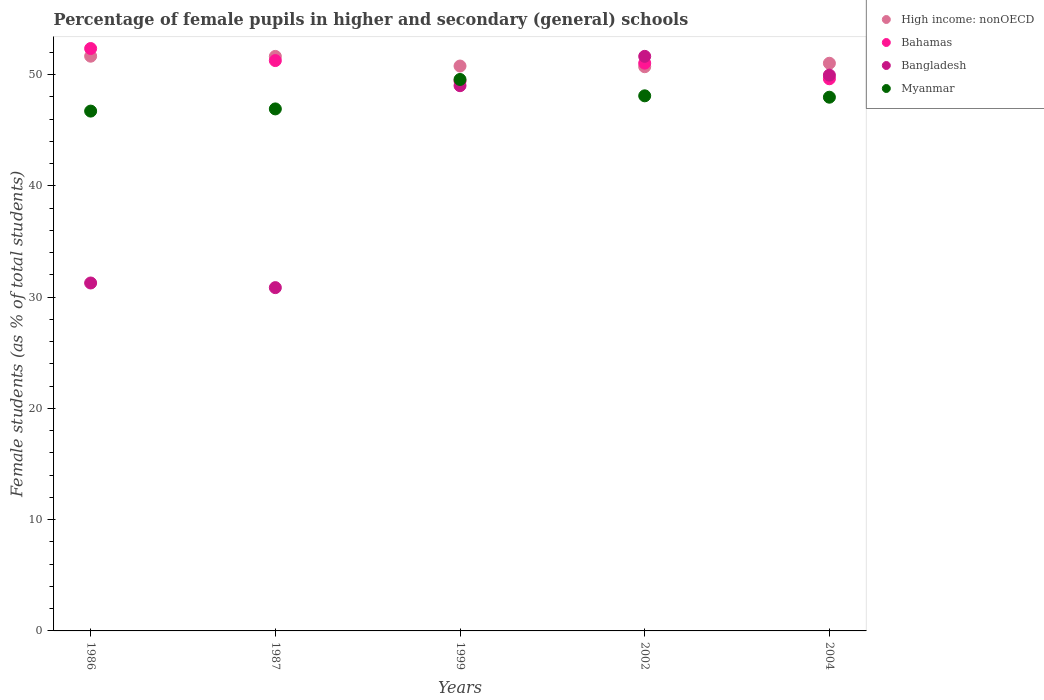How many different coloured dotlines are there?
Give a very brief answer. 4. What is the percentage of female pupils in higher and secondary schools in Bangladesh in 2002?
Provide a short and direct response. 51.64. Across all years, what is the maximum percentage of female pupils in higher and secondary schools in Bahamas?
Give a very brief answer. 52.34. Across all years, what is the minimum percentage of female pupils in higher and secondary schools in Bahamas?
Offer a terse response. 49.43. What is the total percentage of female pupils in higher and secondary schools in Myanmar in the graph?
Provide a succinct answer. 239.25. What is the difference between the percentage of female pupils in higher and secondary schools in High income: nonOECD in 2002 and that in 2004?
Provide a short and direct response. -0.31. What is the difference between the percentage of female pupils in higher and secondary schools in Bangladesh in 1986 and the percentage of female pupils in higher and secondary schools in High income: nonOECD in 1987?
Give a very brief answer. -20.36. What is the average percentage of female pupils in higher and secondary schools in Bahamas per year?
Your answer should be very brief. 50.73. In the year 1999, what is the difference between the percentage of female pupils in higher and secondary schools in High income: nonOECD and percentage of female pupils in higher and secondary schools in Myanmar?
Offer a terse response. 1.21. In how many years, is the percentage of female pupils in higher and secondary schools in Bangladesh greater than 48 %?
Give a very brief answer. 3. What is the ratio of the percentage of female pupils in higher and secondary schools in Bahamas in 2002 to that in 2004?
Provide a short and direct response. 1.03. What is the difference between the highest and the second highest percentage of female pupils in higher and secondary schools in Bangladesh?
Your response must be concise. 1.69. What is the difference between the highest and the lowest percentage of female pupils in higher and secondary schools in High income: nonOECD?
Ensure brevity in your answer.  0.94. In how many years, is the percentage of female pupils in higher and secondary schools in Bahamas greater than the average percentage of female pupils in higher and secondary schools in Bahamas taken over all years?
Your response must be concise. 3. Is it the case that in every year, the sum of the percentage of female pupils in higher and secondary schools in Bangladesh and percentage of female pupils in higher and secondary schools in High income: nonOECD  is greater than the percentage of female pupils in higher and secondary schools in Bahamas?
Your answer should be very brief. Yes. Is the percentage of female pupils in higher and secondary schools in Myanmar strictly greater than the percentage of female pupils in higher and secondary schools in High income: nonOECD over the years?
Your answer should be very brief. No. How many dotlines are there?
Ensure brevity in your answer.  4. How many years are there in the graph?
Ensure brevity in your answer.  5. What is the difference between two consecutive major ticks on the Y-axis?
Keep it short and to the point. 10. Does the graph contain any zero values?
Your answer should be compact. No. Does the graph contain grids?
Offer a very short reply. No. Where does the legend appear in the graph?
Your answer should be very brief. Top right. How many legend labels are there?
Ensure brevity in your answer.  4. How are the legend labels stacked?
Make the answer very short. Vertical. What is the title of the graph?
Give a very brief answer. Percentage of female pupils in higher and secondary (general) schools. Does "Togo" appear as one of the legend labels in the graph?
Your response must be concise. No. What is the label or title of the X-axis?
Offer a very short reply. Years. What is the label or title of the Y-axis?
Your response must be concise. Female students (as % of total students). What is the Female students (as % of total students) of High income: nonOECD in 1986?
Make the answer very short. 51.65. What is the Female students (as % of total students) of Bahamas in 1986?
Give a very brief answer. 52.34. What is the Female students (as % of total students) in Bangladesh in 1986?
Offer a very short reply. 31.27. What is the Female students (as % of total students) in Myanmar in 1986?
Provide a short and direct response. 46.72. What is the Female students (as % of total students) of High income: nonOECD in 1987?
Offer a very short reply. 51.63. What is the Female students (as % of total students) in Bahamas in 1987?
Make the answer very short. 51.26. What is the Female students (as % of total students) of Bangladesh in 1987?
Ensure brevity in your answer.  30.85. What is the Female students (as % of total students) of Myanmar in 1987?
Your answer should be very brief. 46.91. What is the Female students (as % of total students) in High income: nonOECD in 1999?
Keep it short and to the point. 50.77. What is the Female students (as % of total students) in Bahamas in 1999?
Keep it short and to the point. 49.43. What is the Female students (as % of total students) in Bangladesh in 1999?
Your response must be concise. 49. What is the Female students (as % of total students) in Myanmar in 1999?
Your response must be concise. 49.56. What is the Female students (as % of total students) of High income: nonOECD in 2002?
Offer a very short reply. 50.71. What is the Female students (as % of total students) in Bahamas in 2002?
Give a very brief answer. 51.03. What is the Female students (as % of total students) of Bangladesh in 2002?
Provide a short and direct response. 51.64. What is the Female students (as % of total students) of Myanmar in 2002?
Provide a succinct answer. 48.09. What is the Female students (as % of total students) of High income: nonOECD in 2004?
Your response must be concise. 51.02. What is the Female students (as % of total students) of Bahamas in 2004?
Make the answer very short. 49.62. What is the Female students (as % of total students) in Bangladesh in 2004?
Make the answer very short. 49.95. What is the Female students (as % of total students) in Myanmar in 2004?
Ensure brevity in your answer.  47.97. Across all years, what is the maximum Female students (as % of total students) in High income: nonOECD?
Your answer should be compact. 51.65. Across all years, what is the maximum Female students (as % of total students) of Bahamas?
Ensure brevity in your answer.  52.34. Across all years, what is the maximum Female students (as % of total students) in Bangladesh?
Your response must be concise. 51.64. Across all years, what is the maximum Female students (as % of total students) of Myanmar?
Provide a short and direct response. 49.56. Across all years, what is the minimum Female students (as % of total students) in High income: nonOECD?
Offer a terse response. 50.71. Across all years, what is the minimum Female students (as % of total students) of Bahamas?
Give a very brief answer. 49.43. Across all years, what is the minimum Female students (as % of total students) in Bangladesh?
Provide a short and direct response. 30.85. Across all years, what is the minimum Female students (as % of total students) in Myanmar?
Keep it short and to the point. 46.72. What is the total Female students (as % of total students) of High income: nonOECD in the graph?
Ensure brevity in your answer.  255.77. What is the total Female students (as % of total students) of Bahamas in the graph?
Your answer should be compact. 253.67. What is the total Female students (as % of total students) in Bangladesh in the graph?
Offer a very short reply. 212.71. What is the total Female students (as % of total students) in Myanmar in the graph?
Make the answer very short. 239.25. What is the difference between the Female students (as % of total students) in High income: nonOECD in 1986 and that in 1987?
Offer a very short reply. 0.02. What is the difference between the Female students (as % of total students) of Bahamas in 1986 and that in 1987?
Offer a very short reply. 1.08. What is the difference between the Female students (as % of total students) in Bangladesh in 1986 and that in 1987?
Keep it short and to the point. 0.42. What is the difference between the Female students (as % of total students) in Myanmar in 1986 and that in 1987?
Offer a very short reply. -0.2. What is the difference between the Female students (as % of total students) of High income: nonOECD in 1986 and that in 1999?
Offer a very short reply. 0.88. What is the difference between the Female students (as % of total students) of Bahamas in 1986 and that in 1999?
Keep it short and to the point. 2.92. What is the difference between the Female students (as % of total students) in Bangladesh in 1986 and that in 1999?
Make the answer very short. -17.73. What is the difference between the Female students (as % of total students) in Myanmar in 1986 and that in 1999?
Provide a succinct answer. -2.84. What is the difference between the Female students (as % of total students) in High income: nonOECD in 1986 and that in 2002?
Provide a succinct answer. 0.94. What is the difference between the Female students (as % of total students) in Bahamas in 1986 and that in 2002?
Your answer should be compact. 1.31. What is the difference between the Female students (as % of total students) in Bangladesh in 1986 and that in 2002?
Your response must be concise. -20.37. What is the difference between the Female students (as % of total students) in Myanmar in 1986 and that in 2002?
Offer a terse response. -1.37. What is the difference between the Female students (as % of total students) in High income: nonOECD in 1986 and that in 2004?
Provide a short and direct response. 0.63. What is the difference between the Female students (as % of total students) in Bahamas in 1986 and that in 2004?
Make the answer very short. 2.72. What is the difference between the Female students (as % of total students) of Bangladesh in 1986 and that in 2004?
Your response must be concise. -18.68. What is the difference between the Female students (as % of total students) of Myanmar in 1986 and that in 2004?
Your answer should be compact. -1.25. What is the difference between the Female students (as % of total students) in High income: nonOECD in 1987 and that in 1999?
Your response must be concise. 0.87. What is the difference between the Female students (as % of total students) of Bahamas in 1987 and that in 1999?
Give a very brief answer. 1.83. What is the difference between the Female students (as % of total students) in Bangladesh in 1987 and that in 1999?
Offer a terse response. -18.15. What is the difference between the Female students (as % of total students) in Myanmar in 1987 and that in 1999?
Provide a short and direct response. -2.65. What is the difference between the Female students (as % of total students) of High income: nonOECD in 1987 and that in 2002?
Give a very brief answer. 0.93. What is the difference between the Female students (as % of total students) in Bahamas in 1987 and that in 2002?
Provide a succinct answer. 0.23. What is the difference between the Female students (as % of total students) in Bangladesh in 1987 and that in 2002?
Provide a succinct answer. -20.79. What is the difference between the Female students (as % of total students) of Myanmar in 1987 and that in 2002?
Provide a short and direct response. -1.18. What is the difference between the Female students (as % of total students) in High income: nonOECD in 1987 and that in 2004?
Your answer should be compact. 0.62. What is the difference between the Female students (as % of total students) in Bahamas in 1987 and that in 2004?
Provide a succinct answer. 1.64. What is the difference between the Female students (as % of total students) in Bangladesh in 1987 and that in 2004?
Offer a terse response. -19.1. What is the difference between the Female students (as % of total students) of Myanmar in 1987 and that in 2004?
Keep it short and to the point. -1.05. What is the difference between the Female students (as % of total students) of High income: nonOECD in 1999 and that in 2002?
Your answer should be compact. 0.06. What is the difference between the Female students (as % of total students) in Bahamas in 1999 and that in 2002?
Provide a succinct answer. -1.6. What is the difference between the Female students (as % of total students) in Bangladesh in 1999 and that in 2002?
Offer a very short reply. -2.64. What is the difference between the Female students (as % of total students) of Myanmar in 1999 and that in 2002?
Make the answer very short. 1.47. What is the difference between the Female students (as % of total students) of High income: nonOECD in 1999 and that in 2004?
Provide a succinct answer. -0.25. What is the difference between the Female students (as % of total students) of Bahamas in 1999 and that in 2004?
Keep it short and to the point. -0.2. What is the difference between the Female students (as % of total students) in Bangladesh in 1999 and that in 2004?
Your answer should be very brief. -0.95. What is the difference between the Female students (as % of total students) in Myanmar in 1999 and that in 2004?
Provide a short and direct response. 1.59. What is the difference between the Female students (as % of total students) of High income: nonOECD in 2002 and that in 2004?
Offer a very short reply. -0.31. What is the difference between the Female students (as % of total students) of Bahamas in 2002 and that in 2004?
Give a very brief answer. 1.4. What is the difference between the Female students (as % of total students) of Bangladesh in 2002 and that in 2004?
Offer a very short reply. 1.69. What is the difference between the Female students (as % of total students) in Myanmar in 2002 and that in 2004?
Provide a succinct answer. 0.12. What is the difference between the Female students (as % of total students) of High income: nonOECD in 1986 and the Female students (as % of total students) of Bahamas in 1987?
Your response must be concise. 0.39. What is the difference between the Female students (as % of total students) in High income: nonOECD in 1986 and the Female students (as % of total students) in Bangladesh in 1987?
Offer a terse response. 20.8. What is the difference between the Female students (as % of total students) of High income: nonOECD in 1986 and the Female students (as % of total students) of Myanmar in 1987?
Your response must be concise. 4.74. What is the difference between the Female students (as % of total students) in Bahamas in 1986 and the Female students (as % of total students) in Bangladesh in 1987?
Your answer should be compact. 21.49. What is the difference between the Female students (as % of total students) of Bahamas in 1986 and the Female students (as % of total students) of Myanmar in 1987?
Your answer should be compact. 5.43. What is the difference between the Female students (as % of total students) of Bangladesh in 1986 and the Female students (as % of total students) of Myanmar in 1987?
Keep it short and to the point. -15.65. What is the difference between the Female students (as % of total students) of High income: nonOECD in 1986 and the Female students (as % of total students) of Bahamas in 1999?
Provide a short and direct response. 2.23. What is the difference between the Female students (as % of total students) of High income: nonOECD in 1986 and the Female students (as % of total students) of Bangladesh in 1999?
Your answer should be compact. 2.65. What is the difference between the Female students (as % of total students) in High income: nonOECD in 1986 and the Female students (as % of total students) in Myanmar in 1999?
Your response must be concise. 2.09. What is the difference between the Female students (as % of total students) in Bahamas in 1986 and the Female students (as % of total students) in Bangladesh in 1999?
Offer a terse response. 3.34. What is the difference between the Female students (as % of total students) of Bahamas in 1986 and the Female students (as % of total students) of Myanmar in 1999?
Offer a terse response. 2.78. What is the difference between the Female students (as % of total students) of Bangladesh in 1986 and the Female students (as % of total students) of Myanmar in 1999?
Your answer should be compact. -18.29. What is the difference between the Female students (as % of total students) of High income: nonOECD in 1986 and the Female students (as % of total students) of Bahamas in 2002?
Provide a short and direct response. 0.62. What is the difference between the Female students (as % of total students) of High income: nonOECD in 1986 and the Female students (as % of total students) of Bangladesh in 2002?
Make the answer very short. 0.01. What is the difference between the Female students (as % of total students) of High income: nonOECD in 1986 and the Female students (as % of total students) of Myanmar in 2002?
Your answer should be very brief. 3.56. What is the difference between the Female students (as % of total students) in Bahamas in 1986 and the Female students (as % of total students) in Bangladesh in 2002?
Offer a terse response. 0.7. What is the difference between the Female students (as % of total students) in Bahamas in 1986 and the Female students (as % of total students) in Myanmar in 2002?
Your answer should be very brief. 4.25. What is the difference between the Female students (as % of total students) of Bangladesh in 1986 and the Female students (as % of total students) of Myanmar in 2002?
Offer a very short reply. -16.82. What is the difference between the Female students (as % of total students) of High income: nonOECD in 1986 and the Female students (as % of total students) of Bahamas in 2004?
Your answer should be very brief. 2.03. What is the difference between the Female students (as % of total students) of High income: nonOECD in 1986 and the Female students (as % of total students) of Bangladesh in 2004?
Make the answer very short. 1.7. What is the difference between the Female students (as % of total students) of High income: nonOECD in 1986 and the Female students (as % of total students) of Myanmar in 2004?
Your answer should be compact. 3.69. What is the difference between the Female students (as % of total students) of Bahamas in 1986 and the Female students (as % of total students) of Bangladesh in 2004?
Provide a short and direct response. 2.39. What is the difference between the Female students (as % of total students) in Bahamas in 1986 and the Female students (as % of total students) in Myanmar in 2004?
Your answer should be compact. 4.37. What is the difference between the Female students (as % of total students) of Bangladesh in 1986 and the Female students (as % of total students) of Myanmar in 2004?
Offer a very short reply. -16.7. What is the difference between the Female students (as % of total students) in High income: nonOECD in 1987 and the Female students (as % of total students) in Bahamas in 1999?
Ensure brevity in your answer.  2.21. What is the difference between the Female students (as % of total students) of High income: nonOECD in 1987 and the Female students (as % of total students) of Bangladesh in 1999?
Your answer should be very brief. 2.63. What is the difference between the Female students (as % of total students) of High income: nonOECD in 1987 and the Female students (as % of total students) of Myanmar in 1999?
Give a very brief answer. 2.07. What is the difference between the Female students (as % of total students) in Bahamas in 1987 and the Female students (as % of total students) in Bangladesh in 1999?
Your response must be concise. 2.26. What is the difference between the Female students (as % of total students) in Bahamas in 1987 and the Female students (as % of total students) in Myanmar in 1999?
Your response must be concise. 1.7. What is the difference between the Female students (as % of total students) of Bangladesh in 1987 and the Female students (as % of total students) of Myanmar in 1999?
Make the answer very short. -18.71. What is the difference between the Female students (as % of total students) in High income: nonOECD in 1987 and the Female students (as % of total students) in Bahamas in 2002?
Your answer should be very brief. 0.61. What is the difference between the Female students (as % of total students) in High income: nonOECD in 1987 and the Female students (as % of total students) in Bangladesh in 2002?
Your answer should be very brief. -0. What is the difference between the Female students (as % of total students) in High income: nonOECD in 1987 and the Female students (as % of total students) in Myanmar in 2002?
Your answer should be compact. 3.54. What is the difference between the Female students (as % of total students) of Bahamas in 1987 and the Female students (as % of total students) of Bangladesh in 2002?
Provide a succinct answer. -0.38. What is the difference between the Female students (as % of total students) of Bahamas in 1987 and the Female students (as % of total students) of Myanmar in 2002?
Your response must be concise. 3.17. What is the difference between the Female students (as % of total students) in Bangladesh in 1987 and the Female students (as % of total students) in Myanmar in 2002?
Your answer should be compact. -17.24. What is the difference between the Female students (as % of total students) of High income: nonOECD in 1987 and the Female students (as % of total students) of Bahamas in 2004?
Offer a very short reply. 2.01. What is the difference between the Female students (as % of total students) of High income: nonOECD in 1987 and the Female students (as % of total students) of Bangladesh in 2004?
Give a very brief answer. 1.68. What is the difference between the Female students (as % of total students) of High income: nonOECD in 1987 and the Female students (as % of total students) of Myanmar in 2004?
Make the answer very short. 3.67. What is the difference between the Female students (as % of total students) in Bahamas in 1987 and the Female students (as % of total students) in Bangladesh in 2004?
Make the answer very short. 1.31. What is the difference between the Female students (as % of total students) in Bahamas in 1987 and the Female students (as % of total students) in Myanmar in 2004?
Ensure brevity in your answer.  3.29. What is the difference between the Female students (as % of total students) of Bangladesh in 1987 and the Female students (as % of total students) of Myanmar in 2004?
Make the answer very short. -17.11. What is the difference between the Female students (as % of total students) of High income: nonOECD in 1999 and the Female students (as % of total students) of Bahamas in 2002?
Provide a short and direct response. -0.26. What is the difference between the Female students (as % of total students) of High income: nonOECD in 1999 and the Female students (as % of total students) of Bangladesh in 2002?
Provide a short and direct response. -0.87. What is the difference between the Female students (as % of total students) in High income: nonOECD in 1999 and the Female students (as % of total students) in Myanmar in 2002?
Give a very brief answer. 2.68. What is the difference between the Female students (as % of total students) of Bahamas in 1999 and the Female students (as % of total students) of Bangladesh in 2002?
Offer a terse response. -2.21. What is the difference between the Female students (as % of total students) in Bahamas in 1999 and the Female students (as % of total students) in Myanmar in 2002?
Provide a short and direct response. 1.33. What is the difference between the Female students (as % of total students) of Bangladesh in 1999 and the Female students (as % of total students) of Myanmar in 2002?
Give a very brief answer. 0.91. What is the difference between the Female students (as % of total students) in High income: nonOECD in 1999 and the Female students (as % of total students) in Bahamas in 2004?
Your answer should be very brief. 1.14. What is the difference between the Female students (as % of total students) of High income: nonOECD in 1999 and the Female students (as % of total students) of Bangladesh in 2004?
Your answer should be compact. 0.82. What is the difference between the Female students (as % of total students) of High income: nonOECD in 1999 and the Female students (as % of total students) of Myanmar in 2004?
Give a very brief answer. 2.8. What is the difference between the Female students (as % of total students) of Bahamas in 1999 and the Female students (as % of total students) of Bangladesh in 2004?
Keep it short and to the point. -0.52. What is the difference between the Female students (as % of total students) of Bahamas in 1999 and the Female students (as % of total students) of Myanmar in 2004?
Your answer should be compact. 1.46. What is the difference between the Female students (as % of total students) in Bangladesh in 1999 and the Female students (as % of total students) in Myanmar in 2004?
Your response must be concise. 1.03. What is the difference between the Female students (as % of total students) in High income: nonOECD in 2002 and the Female students (as % of total students) in Bahamas in 2004?
Offer a terse response. 1.08. What is the difference between the Female students (as % of total students) of High income: nonOECD in 2002 and the Female students (as % of total students) of Bangladesh in 2004?
Your answer should be very brief. 0.76. What is the difference between the Female students (as % of total students) in High income: nonOECD in 2002 and the Female students (as % of total students) in Myanmar in 2004?
Give a very brief answer. 2.74. What is the difference between the Female students (as % of total students) in Bahamas in 2002 and the Female students (as % of total students) in Bangladesh in 2004?
Ensure brevity in your answer.  1.08. What is the difference between the Female students (as % of total students) of Bahamas in 2002 and the Female students (as % of total students) of Myanmar in 2004?
Offer a very short reply. 3.06. What is the difference between the Female students (as % of total students) of Bangladesh in 2002 and the Female students (as % of total students) of Myanmar in 2004?
Your answer should be very brief. 3.67. What is the average Female students (as % of total students) of High income: nonOECD per year?
Keep it short and to the point. 51.15. What is the average Female students (as % of total students) in Bahamas per year?
Your answer should be very brief. 50.73. What is the average Female students (as % of total students) in Bangladesh per year?
Your response must be concise. 42.54. What is the average Female students (as % of total students) of Myanmar per year?
Your response must be concise. 47.85. In the year 1986, what is the difference between the Female students (as % of total students) of High income: nonOECD and Female students (as % of total students) of Bahamas?
Offer a very short reply. -0.69. In the year 1986, what is the difference between the Female students (as % of total students) in High income: nonOECD and Female students (as % of total students) in Bangladesh?
Provide a succinct answer. 20.38. In the year 1986, what is the difference between the Female students (as % of total students) of High income: nonOECD and Female students (as % of total students) of Myanmar?
Provide a succinct answer. 4.93. In the year 1986, what is the difference between the Female students (as % of total students) of Bahamas and Female students (as % of total students) of Bangladesh?
Your answer should be very brief. 21.07. In the year 1986, what is the difference between the Female students (as % of total students) in Bahamas and Female students (as % of total students) in Myanmar?
Give a very brief answer. 5.62. In the year 1986, what is the difference between the Female students (as % of total students) in Bangladesh and Female students (as % of total students) in Myanmar?
Offer a terse response. -15.45. In the year 1987, what is the difference between the Female students (as % of total students) in High income: nonOECD and Female students (as % of total students) in Bahamas?
Your response must be concise. 0.38. In the year 1987, what is the difference between the Female students (as % of total students) of High income: nonOECD and Female students (as % of total students) of Bangladesh?
Ensure brevity in your answer.  20.78. In the year 1987, what is the difference between the Female students (as % of total students) in High income: nonOECD and Female students (as % of total students) in Myanmar?
Your answer should be compact. 4.72. In the year 1987, what is the difference between the Female students (as % of total students) of Bahamas and Female students (as % of total students) of Bangladesh?
Your answer should be very brief. 20.41. In the year 1987, what is the difference between the Female students (as % of total students) of Bahamas and Female students (as % of total students) of Myanmar?
Make the answer very short. 4.34. In the year 1987, what is the difference between the Female students (as % of total students) in Bangladesh and Female students (as % of total students) in Myanmar?
Keep it short and to the point. -16.06. In the year 1999, what is the difference between the Female students (as % of total students) in High income: nonOECD and Female students (as % of total students) in Bahamas?
Provide a short and direct response. 1.34. In the year 1999, what is the difference between the Female students (as % of total students) of High income: nonOECD and Female students (as % of total students) of Bangladesh?
Your answer should be compact. 1.77. In the year 1999, what is the difference between the Female students (as % of total students) in High income: nonOECD and Female students (as % of total students) in Myanmar?
Give a very brief answer. 1.21. In the year 1999, what is the difference between the Female students (as % of total students) in Bahamas and Female students (as % of total students) in Bangladesh?
Give a very brief answer. 0.42. In the year 1999, what is the difference between the Female students (as % of total students) in Bahamas and Female students (as % of total students) in Myanmar?
Your answer should be compact. -0.13. In the year 1999, what is the difference between the Female students (as % of total students) in Bangladesh and Female students (as % of total students) in Myanmar?
Your response must be concise. -0.56. In the year 2002, what is the difference between the Female students (as % of total students) of High income: nonOECD and Female students (as % of total students) of Bahamas?
Your response must be concise. -0.32. In the year 2002, what is the difference between the Female students (as % of total students) in High income: nonOECD and Female students (as % of total students) in Bangladesh?
Provide a succinct answer. -0.93. In the year 2002, what is the difference between the Female students (as % of total students) in High income: nonOECD and Female students (as % of total students) in Myanmar?
Provide a succinct answer. 2.62. In the year 2002, what is the difference between the Female students (as % of total students) in Bahamas and Female students (as % of total students) in Bangladesh?
Give a very brief answer. -0.61. In the year 2002, what is the difference between the Female students (as % of total students) of Bahamas and Female students (as % of total students) of Myanmar?
Offer a terse response. 2.94. In the year 2002, what is the difference between the Female students (as % of total students) of Bangladesh and Female students (as % of total students) of Myanmar?
Provide a short and direct response. 3.55. In the year 2004, what is the difference between the Female students (as % of total students) of High income: nonOECD and Female students (as % of total students) of Bahamas?
Keep it short and to the point. 1.39. In the year 2004, what is the difference between the Female students (as % of total students) of High income: nonOECD and Female students (as % of total students) of Bangladesh?
Offer a terse response. 1.07. In the year 2004, what is the difference between the Female students (as % of total students) in High income: nonOECD and Female students (as % of total students) in Myanmar?
Keep it short and to the point. 3.05. In the year 2004, what is the difference between the Female students (as % of total students) of Bahamas and Female students (as % of total students) of Bangladesh?
Your response must be concise. -0.33. In the year 2004, what is the difference between the Female students (as % of total students) of Bahamas and Female students (as % of total students) of Myanmar?
Provide a short and direct response. 1.66. In the year 2004, what is the difference between the Female students (as % of total students) in Bangladesh and Female students (as % of total students) in Myanmar?
Your answer should be very brief. 1.98. What is the ratio of the Female students (as % of total students) in High income: nonOECD in 1986 to that in 1987?
Offer a very short reply. 1. What is the ratio of the Female students (as % of total students) in Bahamas in 1986 to that in 1987?
Your answer should be very brief. 1.02. What is the ratio of the Female students (as % of total students) in Bangladesh in 1986 to that in 1987?
Your answer should be compact. 1.01. What is the ratio of the Female students (as % of total students) in Myanmar in 1986 to that in 1987?
Make the answer very short. 1. What is the ratio of the Female students (as % of total students) of High income: nonOECD in 1986 to that in 1999?
Give a very brief answer. 1.02. What is the ratio of the Female students (as % of total students) in Bahamas in 1986 to that in 1999?
Provide a short and direct response. 1.06. What is the ratio of the Female students (as % of total students) in Bangladesh in 1986 to that in 1999?
Make the answer very short. 0.64. What is the ratio of the Female students (as % of total students) of Myanmar in 1986 to that in 1999?
Your response must be concise. 0.94. What is the ratio of the Female students (as % of total students) of High income: nonOECD in 1986 to that in 2002?
Offer a very short reply. 1.02. What is the ratio of the Female students (as % of total students) in Bahamas in 1986 to that in 2002?
Keep it short and to the point. 1.03. What is the ratio of the Female students (as % of total students) of Bangladesh in 1986 to that in 2002?
Provide a short and direct response. 0.61. What is the ratio of the Female students (as % of total students) of Myanmar in 1986 to that in 2002?
Give a very brief answer. 0.97. What is the ratio of the Female students (as % of total students) of High income: nonOECD in 1986 to that in 2004?
Provide a short and direct response. 1.01. What is the ratio of the Female students (as % of total students) in Bahamas in 1986 to that in 2004?
Offer a terse response. 1.05. What is the ratio of the Female students (as % of total students) in Bangladesh in 1986 to that in 2004?
Give a very brief answer. 0.63. What is the ratio of the Female students (as % of total students) in High income: nonOECD in 1987 to that in 1999?
Offer a very short reply. 1.02. What is the ratio of the Female students (as % of total students) in Bahamas in 1987 to that in 1999?
Ensure brevity in your answer.  1.04. What is the ratio of the Female students (as % of total students) in Bangladesh in 1987 to that in 1999?
Offer a terse response. 0.63. What is the ratio of the Female students (as % of total students) in Myanmar in 1987 to that in 1999?
Provide a short and direct response. 0.95. What is the ratio of the Female students (as % of total students) in High income: nonOECD in 1987 to that in 2002?
Offer a terse response. 1.02. What is the ratio of the Female students (as % of total students) in Bahamas in 1987 to that in 2002?
Provide a succinct answer. 1. What is the ratio of the Female students (as % of total students) of Bangladesh in 1987 to that in 2002?
Keep it short and to the point. 0.6. What is the ratio of the Female students (as % of total students) in Myanmar in 1987 to that in 2002?
Provide a succinct answer. 0.98. What is the ratio of the Female students (as % of total students) of High income: nonOECD in 1987 to that in 2004?
Give a very brief answer. 1.01. What is the ratio of the Female students (as % of total students) of Bahamas in 1987 to that in 2004?
Keep it short and to the point. 1.03. What is the ratio of the Female students (as % of total students) in Bangladesh in 1987 to that in 2004?
Offer a terse response. 0.62. What is the ratio of the Female students (as % of total students) of Myanmar in 1987 to that in 2004?
Ensure brevity in your answer.  0.98. What is the ratio of the Female students (as % of total students) in Bahamas in 1999 to that in 2002?
Provide a succinct answer. 0.97. What is the ratio of the Female students (as % of total students) in Bangladesh in 1999 to that in 2002?
Provide a succinct answer. 0.95. What is the ratio of the Female students (as % of total students) of Myanmar in 1999 to that in 2002?
Provide a succinct answer. 1.03. What is the ratio of the Female students (as % of total students) in High income: nonOECD in 1999 to that in 2004?
Provide a short and direct response. 1. What is the ratio of the Female students (as % of total students) in Bahamas in 1999 to that in 2004?
Your answer should be compact. 1. What is the ratio of the Female students (as % of total students) in Bangladesh in 1999 to that in 2004?
Offer a terse response. 0.98. What is the ratio of the Female students (as % of total students) of Myanmar in 1999 to that in 2004?
Keep it short and to the point. 1.03. What is the ratio of the Female students (as % of total students) of High income: nonOECD in 2002 to that in 2004?
Give a very brief answer. 0.99. What is the ratio of the Female students (as % of total students) in Bahamas in 2002 to that in 2004?
Make the answer very short. 1.03. What is the ratio of the Female students (as % of total students) in Bangladesh in 2002 to that in 2004?
Provide a short and direct response. 1.03. What is the ratio of the Female students (as % of total students) in Myanmar in 2002 to that in 2004?
Offer a terse response. 1. What is the difference between the highest and the second highest Female students (as % of total students) of High income: nonOECD?
Ensure brevity in your answer.  0.02. What is the difference between the highest and the second highest Female students (as % of total students) in Bahamas?
Your response must be concise. 1.08. What is the difference between the highest and the second highest Female students (as % of total students) of Bangladesh?
Keep it short and to the point. 1.69. What is the difference between the highest and the second highest Female students (as % of total students) in Myanmar?
Offer a terse response. 1.47. What is the difference between the highest and the lowest Female students (as % of total students) of High income: nonOECD?
Your response must be concise. 0.94. What is the difference between the highest and the lowest Female students (as % of total students) in Bahamas?
Provide a short and direct response. 2.92. What is the difference between the highest and the lowest Female students (as % of total students) of Bangladesh?
Give a very brief answer. 20.79. What is the difference between the highest and the lowest Female students (as % of total students) of Myanmar?
Offer a terse response. 2.84. 